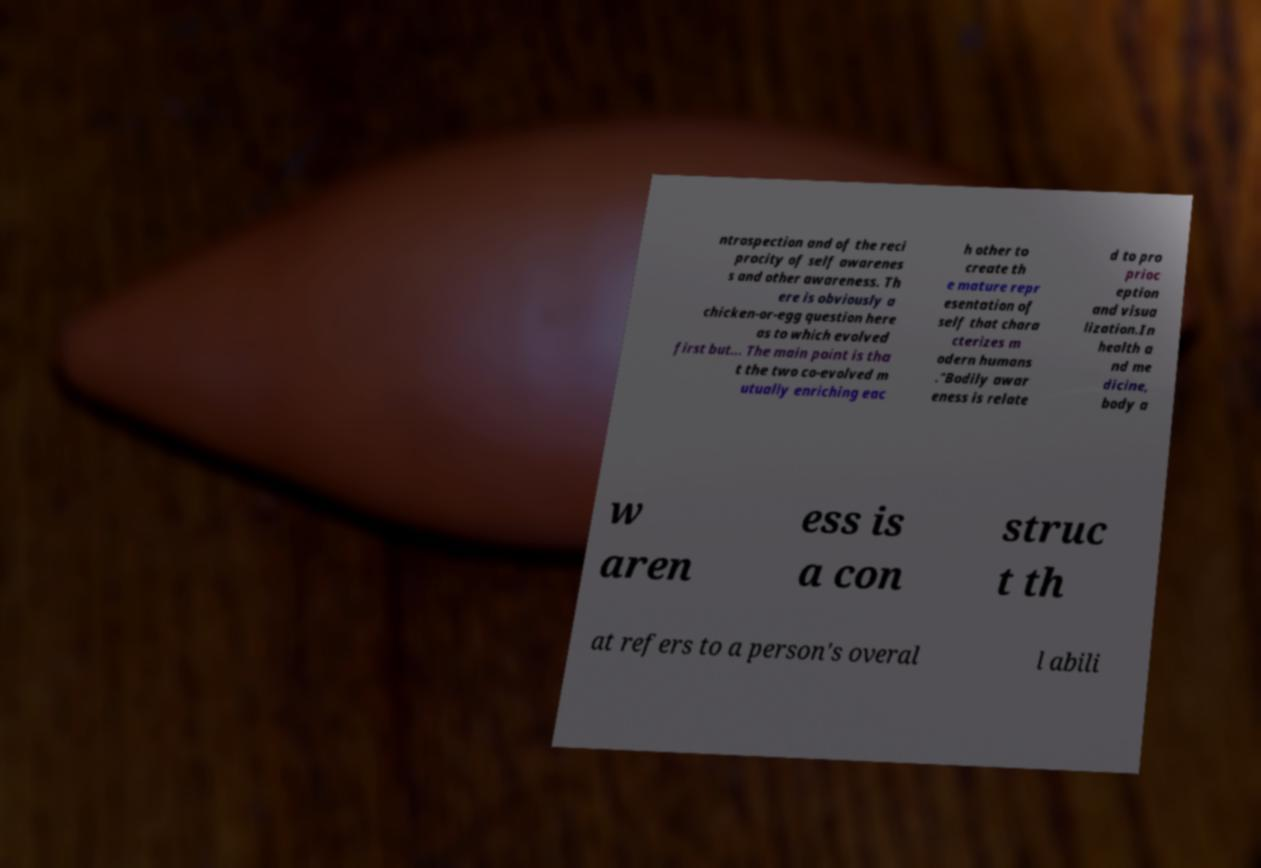Can you accurately transcribe the text from the provided image for me? ntrospection and of the reci procity of self awarenes s and other awareness. Th ere is obviously a chicken-or-egg question here as to which evolved first but... The main point is tha t the two co-evolved m utually enriching eac h other to create th e mature repr esentation of self that chara cterizes m odern humans ."Bodily awar eness is relate d to pro prioc eption and visua lization.In health a nd me dicine, body a w aren ess is a con struc t th at refers to a person's overal l abili 